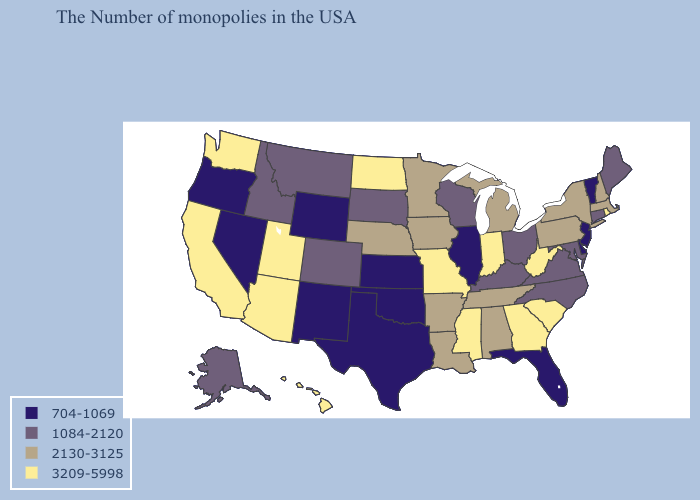Name the states that have a value in the range 3209-5998?
Write a very short answer. Rhode Island, South Carolina, West Virginia, Georgia, Indiana, Mississippi, Missouri, North Dakota, Utah, Arizona, California, Washington, Hawaii. What is the highest value in states that border Michigan?
Short answer required. 3209-5998. Name the states that have a value in the range 704-1069?
Write a very short answer. Vermont, New Jersey, Delaware, Florida, Illinois, Kansas, Oklahoma, Texas, Wyoming, New Mexico, Nevada, Oregon. Which states hav the highest value in the Northeast?
Answer briefly. Rhode Island. What is the value of Virginia?
Write a very short answer. 1084-2120. What is the value of Delaware?
Write a very short answer. 704-1069. Does Iowa have the same value as Tennessee?
Quick response, please. Yes. Does Alabama have the lowest value in the South?
Keep it brief. No. Among the states that border Missouri , does Oklahoma have the highest value?
Keep it brief. No. Does New Jersey have a lower value than Utah?
Give a very brief answer. Yes. Name the states that have a value in the range 2130-3125?
Quick response, please. Massachusetts, New Hampshire, New York, Pennsylvania, Michigan, Alabama, Tennessee, Louisiana, Arkansas, Minnesota, Iowa, Nebraska. What is the value of Georgia?
Give a very brief answer. 3209-5998. Which states hav the highest value in the West?
Answer briefly. Utah, Arizona, California, Washington, Hawaii. Name the states that have a value in the range 704-1069?
Write a very short answer. Vermont, New Jersey, Delaware, Florida, Illinois, Kansas, Oklahoma, Texas, Wyoming, New Mexico, Nevada, Oregon. Among the states that border North Carolina , does South Carolina have the highest value?
Concise answer only. Yes. 